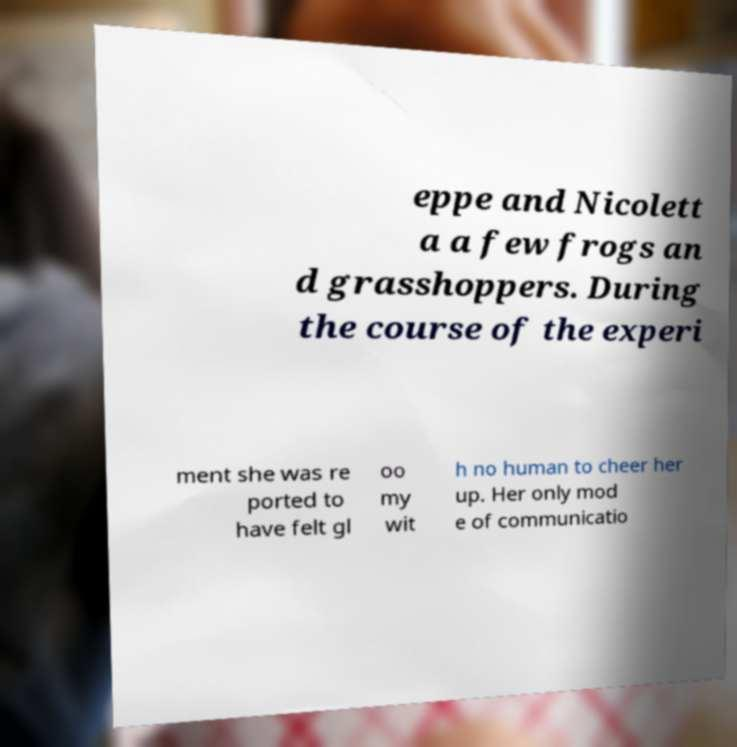What messages or text are displayed in this image? I need them in a readable, typed format. eppe and Nicolett a a few frogs an d grasshoppers. During the course of the experi ment she was re ported to have felt gl oo my wit h no human to cheer her up. Her only mod e of communicatio 